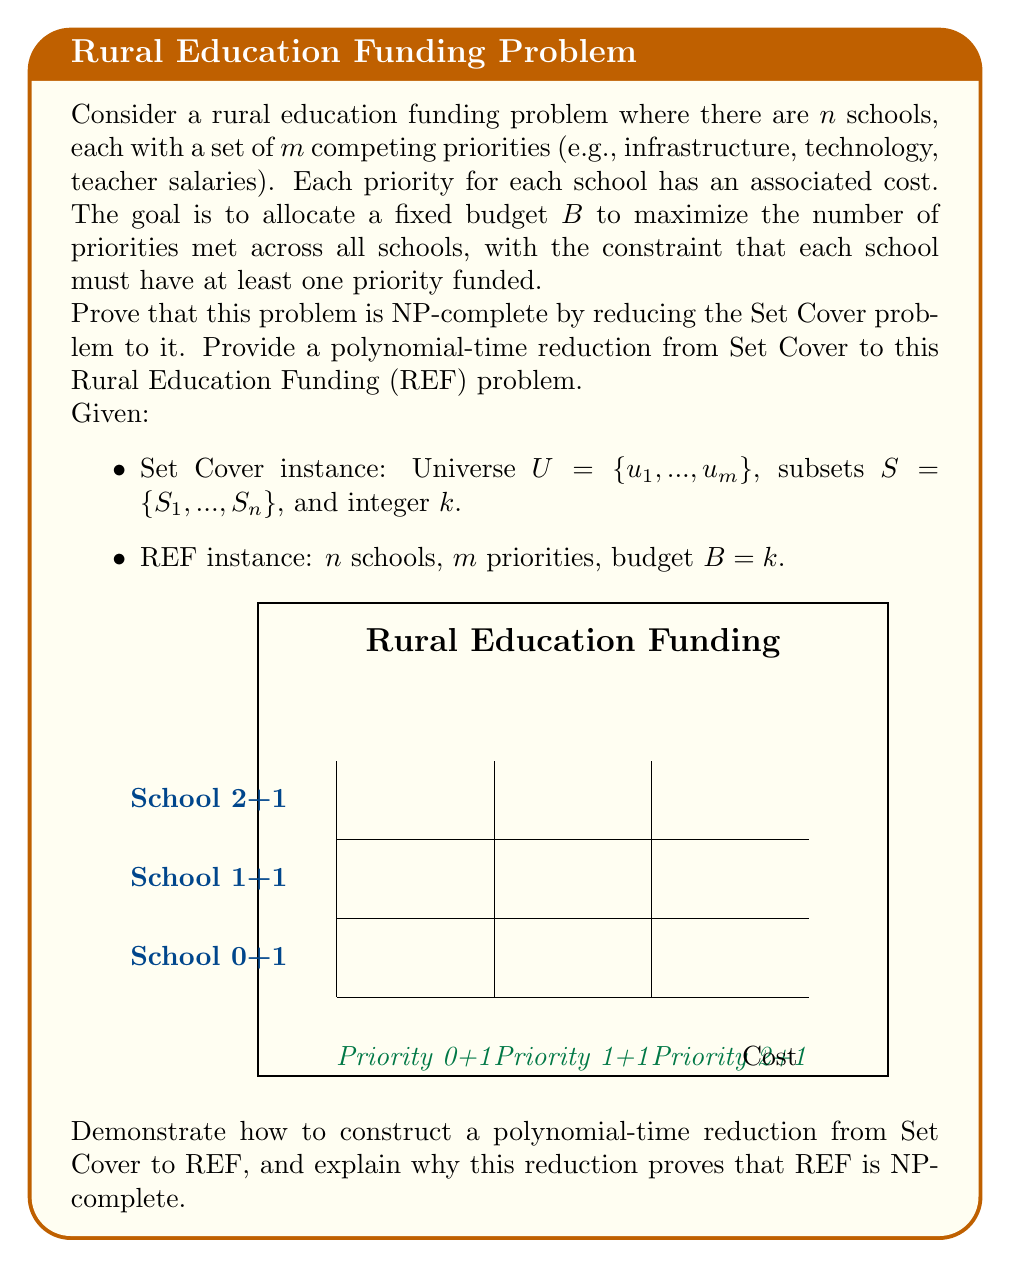Show me your answer to this math problem. To prove that the Rural Education Funding (REF) problem is NP-complete, we need to show that it is in NP and that it is NP-hard. We'll focus on proving it's NP-hard by reducing the Set Cover problem, which is known to be NP-complete, to REF.

Step 1: Show REF is in NP
- A solution to REF can be verified in polynomial time by checking if the budget constraint is met and if each school has at least one priority funded.

Step 2: Reduction from Set Cover to REF
We'll construct a polynomial-time reduction from Set Cover to REF:

a) For each subset $S_i$ in the Set Cover instance, create a school in the REF instance.
b) For each element $u_j$ in the universe $U$, create a priority in the REF instance.
c) Set the cost of priority $j$ for school $i$ to 1 if $u_j \in S_i$, and to $\infty$ (or a very large number) otherwise.
d) Set the budget $B$ in REF to $k$ from the Set Cover instance.

Formally:
$$\text{cost}(i,j) = \begin{cases} 
1 & \text{if } u_j \in S_i \\
\infty & \text{otherwise}
\end{cases}$$

Step 3: Prove the reduction is correct
- If there exists a set cover of size $k$ or less, then there exists a valid funding allocation in REF:
  - Fund the priorities corresponding to the elements covered by each selected subset.
  - This ensures each school (subset) has at least one priority funded and the total cost is at most $k$.

- If there exists a valid funding allocation in REF with budget $k$, then there exists a set cover of size $k$ or less:
  - The funded priorities for each school correspond to the elements covered by the corresponding subset.
  - Since each school has at least one priority funded, all elements are covered.

Step 4: Show the reduction is polynomial-time
- The reduction creates $n$ schools and $m$ priorities, which is linear in the size of the Set Cover instance.
- Setting the costs takes $O(nm)$ time.

Since Set Cover is NP-complete, this reduction proves that REF is NP-hard. Combined with the fact that REF is in NP, we conclude that REF is NP-complete.
Answer: REF is NP-complete. 